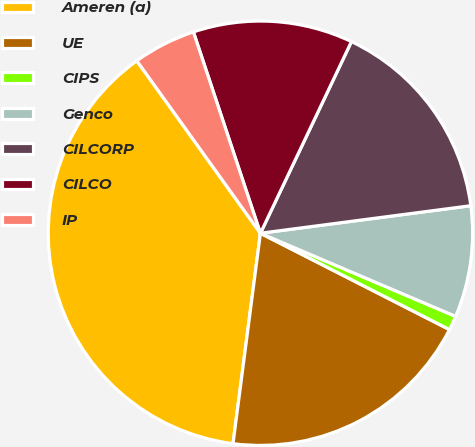Convert chart to OTSL. <chart><loc_0><loc_0><loc_500><loc_500><pie_chart><fcel>Ameren (a)<fcel>UE<fcel>CIPS<fcel>Genco<fcel>CILCORP<fcel>CILCO<fcel>IP<nl><fcel>38.04%<fcel>19.56%<fcel>1.09%<fcel>8.48%<fcel>15.87%<fcel>12.17%<fcel>4.78%<nl></chart> 